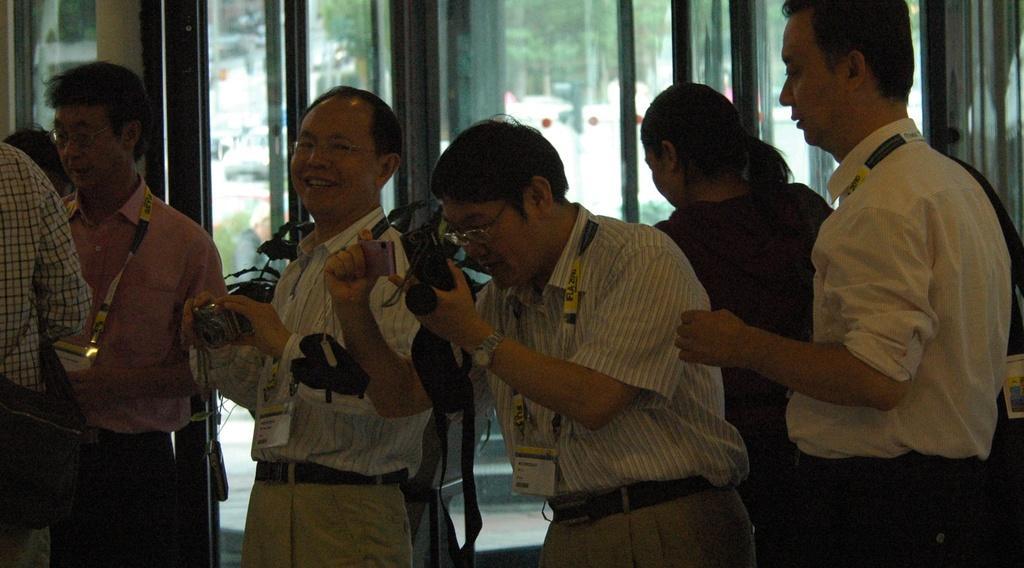Can you describe this image briefly? In the center of the image two mans are standing and camera. On the left side of the image some persons are standing, some of them are holding bag. On the right side of the image lady and man are standing. In the background of the image we can see door, wall, cars, trees. At the bottom of the image there is a floor. 